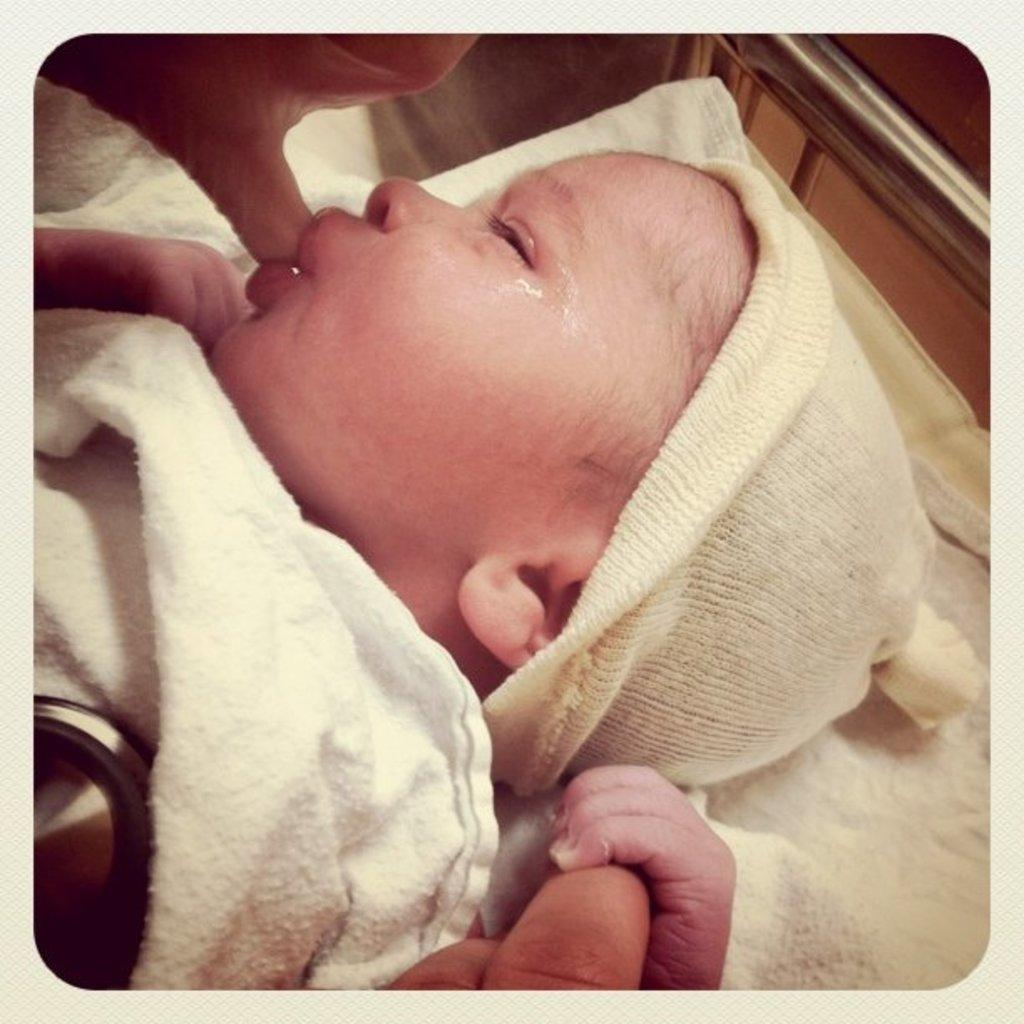What is the main subject of the image? There is a baby wrapped in cloth in the image. Can you describe the hands visible in the image? There is a person's hand at the top of the image and another at the bottom. What is the material of the steel bar in the image? The steel bar is on the right side of the image. What type of bear can be seen interacting with the baby in the image? There is no bear present in the image; it features a baby wrapped in cloth with hands on both sides. What attraction is the baby visiting in the image? There is no indication of an attraction or any specific location in the image. 